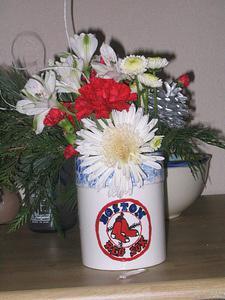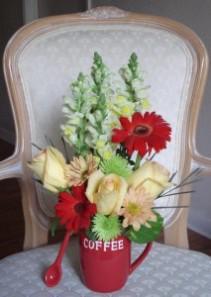The first image is the image on the left, the second image is the image on the right. Assess this claim about the two images: "In one image the object rests on a tablecloth and in the other image it rests on bare wood.". Correct or not? Answer yes or no. Yes. The first image is the image on the left, the second image is the image on the right. For the images shown, is this caption "An image shows a white vase resembling an artichoke, filled with red lily-type flowers and sitting on a table." true? Answer yes or no. No. 